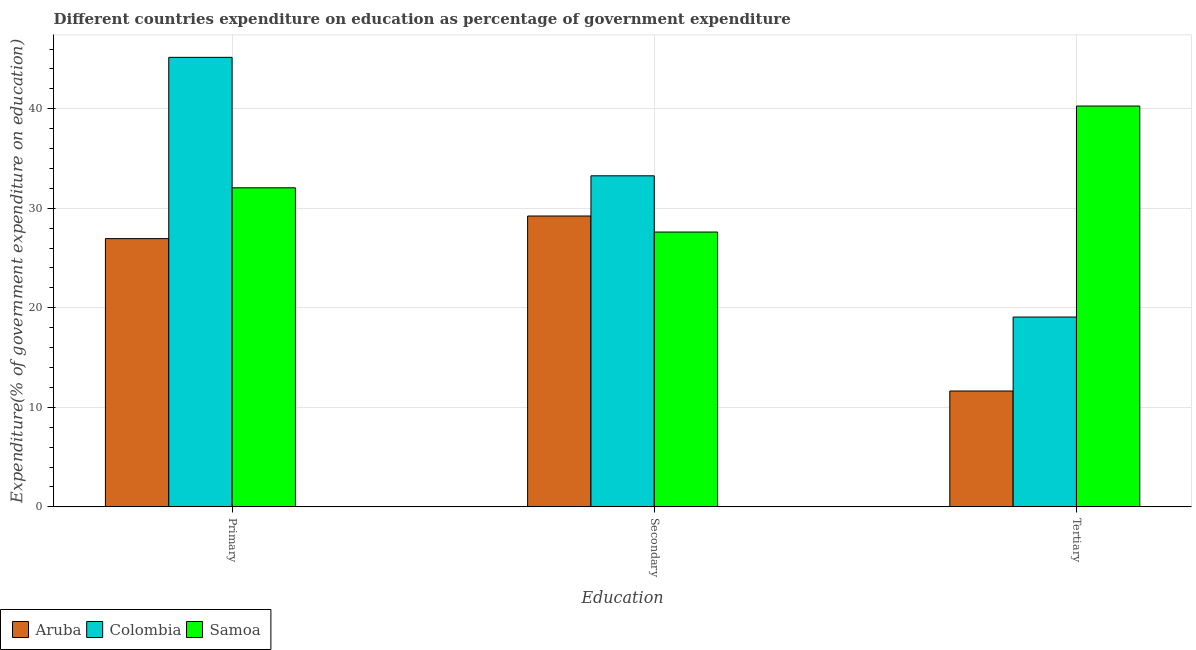How many different coloured bars are there?
Provide a short and direct response. 3. How many groups of bars are there?
Ensure brevity in your answer.  3. Are the number of bars per tick equal to the number of legend labels?
Ensure brevity in your answer.  Yes. Are the number of bars on each tick of the X-axis equal?
Your answer should be very brief. Yes. What is the label of the 2nd group of bars from the left?
Offer a terse response. Secondary. What is the expenditure on tertiary education in Samoa?
Make the answer very short. 40.27. Across all countries, what is the maximum expenditure on tertiary education?
Your response must be concise. 40.27. Across all countries, what is the minimum expenditure on secondary education?
Keep it short and to the point. 27.61. In which country was the expenditure on secondary education minimum?
Offer a terse response. Samoa. What is the total expenditure on tertiary education in the graph?
Offer a very short reply. 70.98. What is the difference between the expenditure on secondary education in Samoa and that in Colombia?
Give a very brief answer. -5.65. What is the difference between the expenditure on tertiary education in Samoa and the expenditure on primary education in Colombia?
Your answer should be compact. -4.89. What is the average expenditure on primary education per country?
Provide a succinct answer. 34.72. What is the difference between the expenditure on primary education and expenditure on secondary education in Samoa?
Provide a short and direct response. 4.44. What is the ratio of the expenditure on secondary education in Colombia to that in Samoa?
Your answer should be very brief. 1.2. Is the difference between the expenditure on tertiary education in Colombia and Samoa greater than the difference between the expenditure on primary education in Colombia and Samoa?
Your answer should be very brief. No. What is the difference between the highest and the second highest expenditure on tertiary education?
Provide a succinct answer. 21.2. What is the difference between the highest and the lowest expenditure on secondary education?
Your answer should be compact. 5.65. Is the sum of the expenditure on secondary education in Samoa and Colombia greater than the maximum expenditure on tertiary education across all countries?
Keep it short and to the point. Yes. What does the 3rd bar from the left in Primary represents?
Your answer should be compact. Samoa. Is it the case that in every country, the sum of the expenditure on primary education and expenditure on secondary education is greater than the expenditure on tertiary education?
Your answer should be compact. Yes. Are all the bars in the graph horizontal?
Your response must be concise. No. Does the graph contain any zero values?
Provide a short and direct response. No. Where does the legend appear in the graph?
Offer a very short reply. Bottom left. How many legend labels are there?
Offer a very short reply. 3. How are the legend labels stacked?
Provide a short and direct response. Horizontal. What is the title of the graph?
Offer a very short reply. Different countries expenditure on education as percentage of government expenditure. What is the label or title of the X-axis?
Your answer should be very brief. Education. What is the label or title of the Y-axis?
Offer a very short reply. Expenditure(% of government expenditure on education). What is the Expenditure(% of government expenditure on education) of Aruba in Primary?
Make the answer very short. 26.95. What is the Expenditure(% of government expenditure on education) in Colombia in Primary?
Ensure brevity in your answer.  45.16. What is the Expenditure(% of government expenditure on education) in Samoa in Primary?
Make the answer very short. 32.05. What is the Expenditure(% of government expenditure on education) of Aruba in Secondary?
Offer a very short reply. 29.22. What is the Expenditure(% of government expenditure on education) in Colombia in Secondary?
Your answer should be compact. 33.26. What is the Expenditure(% of government expenditure on education) of Samoa in Secondary?
Keep it short and to the point. 27.61. What is the Expenditure(% of government expenditure on education) of Aruba in Tertiary?
Make the answer very short. 11.64. What is the Expenditure(% of government expenditure on education) of Colombia in Tertiary?
Provide a succinct answer. 19.07. What is the Expenditure(% of government expenditure on education) of Samoa in Tertiary?
Ensure brevity in your answer.  40.27. Across all Education, what is the maximum Expenditure(% of government expenditure on education) of Aruba?
Provide a short and direct response. 29.22. Across all Education, what is the maximum Expenditure(% of government expenditure on education) in Colombia?
Keep it short and to the point. 45.16. Across all Education, what is the maximum Expenditure(% of government expenditure on education) of Samoa?
Provide a short and direct response. 40.27. Across all Education, what is the minimum Expenditure(% of government expenditure on education) of Aruba?
Your answer should be very brief. 11.64. Across all Education, what is the minimum Expenditure(% of government expenditure on education) of Colombia?
Provide a short and direct response. 19.07. Across all Education, what is the minimum Expenditure(% of government expenditure on education) in Samoa?
Keep it short and to the point. 27.61. What is the total Expenditure(% of government expenditure on education) of Aruba in the graph?
Provide a succinct answer. 67.81. What is the total Expenditure(% of government expenditure on education) of Colombia in the graph?
Make the answer very short. 97.49. What is the total Expenditure(% of government expenditure on education) in Samoa in the graph?
Ensure brevity in your answer.  99.94. What is the difference between the Expenditure(% of government expenditure on education) in Aruba in Primary and that in Secondary?
Give a very brief answer. -2.27. What is the difference between the Expenditure(% of government expenditure on education) of Colombia in Primary and that in Secondary?
Make the answer very short. 11.9. What is the difference between the Expenditure(% of government expenditure on education) of Samoa in Primary and that in Secondary?
Your answer should be very brief. 4.44. What is the difference between the Expenditure(% of government expenditure on education) of Aruba in Primary and that in Tertiary?
Provide a succinct answer. 15.31. What is the difference between the Expenditure(% of government expenditure on education) of Colombia in Primary and that in Tertiary?
Your answer should be compact. 26.09. What is the difference between the Expenditure(% of government expenditure on education) in Samoa in Primary and that in Tertiary?
Offer a terse response. -8.22. What is the difference between the Expenditure(% of government expenditure on education) in Aruba in Secondary and that in Tertiary?
Provide a succinct answer. 17.58. What is the difference between the Expenditure(% of government expenditure on education) of Colombia in Secondary and that in Tertiary?
Give a very brief answer. 14.19. What is the difference between the Expenditure(% of government expenditure on education) of Samoa in Secondary and that in Tertiary?
Give a very brief answer. -12.66. What is the difference between the Expenditure(% of government expenditure on education) of Aruba in Primary and the Expenditure(% of government expenditure on education) of Colombia in Secondary?
Provide a succinct answer. -6.31. What is the difference between the Expenditure(% of government expenditure on education) in Aruba in Primary and the Expenditure(% of government expenditure on education) in Samoa in Secondary?
Provide a succinct answer. -0.66. What is the difference between the Expenditure(% of government expenditure on education) of Colombia in Primary and the Expenditure(% of government expenditure on education) of Samoa in Secondary?
Your answer should be very brief. 17.55. What is the difference between the Expenditure(% of government expenditure on education) in Aruba in Primary and the Expenditure(% of government expenditure on education) in Colombia in Tertiary?
Offer a very short reply. 7.88. What is the difference between the Expenditure(% of government expenditure on education) in Aruba in Primary and the Expenditure(% of government expenditure on education) in Samoa in Tertiary?
Provide a succinct answer. -13.32. What is the difference between the Expenditure(% of government expenditure on education) of Colombia in Primary and the Expenditure(% of government expenditure on education) of Samoa in Tertiary?
Offer a very short reply. 4.89. What is the difference between the Expenditure(% of government expenditure on education) in Aruba in Secondary and the Expenditure(% of government expenditure on education) in Colombia in Tertiary?
Offer a terse response. 10.15. What is the difference between the Expenditure(% of government expenditure on education) in Aruba in Secondary and the Expenditure(% of government expenditure on education) in Samoa in Tertiary?
Ensure brevity in your answer.  -11.05. What is the difference between the Expenditure(% of government expenditure on education) in Colombia in Secondary and the Expenditure(% of government expenditure on education) in Samoa in Tertiary?
Keep it short and to the point. -7.01. What is the average Expenditure(% of government expenditure on education) in Aruba per Education?
Provide a succinct answer. 22.6. What is the average Expenditure(% of government expenditure on education) of Colombia per Education?
Your response must be concise. 32.5. What is the average Expenditure(% of government expenditure on education) of Samoa per Education?
Your response must be concise. 33.31. What is the difference between the Expenditure(% of government expenditure on education) of Aruba and Expenditure(% of government expenditure on education) of Colombia in Primary?
Your response must be concise. -18.21. What is the difference between the Expenditure(% of government expenditure on education) of Aruba and Expenditure(% of government expenditure on education) of Samoa in Primary?
Offer a very short reply. -5.11. What is the difference between the Expenditure(% of government expenditure on education) of Colombia and Expenditure(% of government expenditure on education) of Samoa in Primary?
Ensure brevity in your answer.  13.11. What is the difference between the Expenditure(% of government expenditure on education) of Aruba and Expenditure(% of government expenditure on education) of Colombia in Secondary?
Make the answer very short. -4.04. What is the difference between the Expenditure(% of government expenditure on education) of Aruba and Expenditure(% of government expenditure on education) of Samoa in Secondary?
Offer a terse response. 1.61. What is the difference between the Expenditure(% of government expenditure on education) in Colombia and Expenditure(% of government expenditure on education) in Samoa in Secondary?
Keep it short and to the point. 5.65. What is the difference between the Expenditure(% of government expenditure on education) in Aruba and Expenditure(% of government expenditure on education) in Colombia in Tertiary?
Ensure brevity in your answer.  -7.43. What is the difference between the Expenditure(% of government expenditure on education) of Aruba and Expenditure(% of government expenditure on education) of Samoa in Tertiary?
Offer a very short reply. -28.63. What is the difference between the Expenditure(% of government expenditure on education) in Colombia and Expenditure(% of government expenditure on education) in Samoa in Tertiary?
Ensure brevity in your answer.  -21.2. What is the ratio of the Expenditure(% of government expenditure on education) in Aruba in Primary to that in Secondary?
Your answer should be very brief. 0.92. What is the ratio of the Expenditure(% of government expenditure on education) of Colombia in Primary to that in Secondary?
Provide a succinct answer. 1.36. What is the ratio of the Expenditure(% of government expenditure on education) in Samoa in Primary to that in Secondary?
Ensure brevity in your answer.  1.16. What is the ratio of the Expenditure(% of government expenditure on education) of Aruba in Primary to that in Tertiary?
Offer a very short reply. 2.32. What is the ratio of the Expenditure(% of government expenditure on education) of Colombia in Primary to that in Tertiary?
Make the answer very short. 2.37. What is the ratio of the Expenditure(% of government expenditure on education) of Samoa in Primary to that in Tertiary?
Provide a short and direct response. 0.8. What is the ratio of the Expenditure(% of government expenditure on education) of Aruba in Secondary to that in Tertiary?
Keep it short and to the point. 2.51. What is the ratio of the Expenditure(% of government expenditure on education) of Colombia in Secondary to that in Tertiary?
Give a very brief answer. 1.74. What is the ratio of the Expenditure(% of government expenditure on education) of Samoa in Secondary to that in Tertiary?
Your answer should be very brief. 0.69. What is the difference between the highest and the second highest Expenditure(% of government expenditure on education) in Aruba?
Give a very brief answer. 2.27. What is the difference between the highest and the second highest Expenditure(% of government expenditure on education) of Colombia?
Give a very brief answer. 11.9. What is the difference between the highest and the second highest Expenditure(% of government expenditure on education) in Samoa?
Ensure brevity in your answer.  8.22. What is the difference between the highest and the lowest Expenditure(% of government expenditure on education) in Aruba?
Your response must be concise. 17.58. What is the difference between the highest and the lowest Expenditure(% of government expenditure on education) of Colombia?
Provide a short and direct response. 26.09. What is the difference between the highest and the lowest Expenditure(% of government expenditure on education) of Samoa?
Make the answer very short. 12.66. 